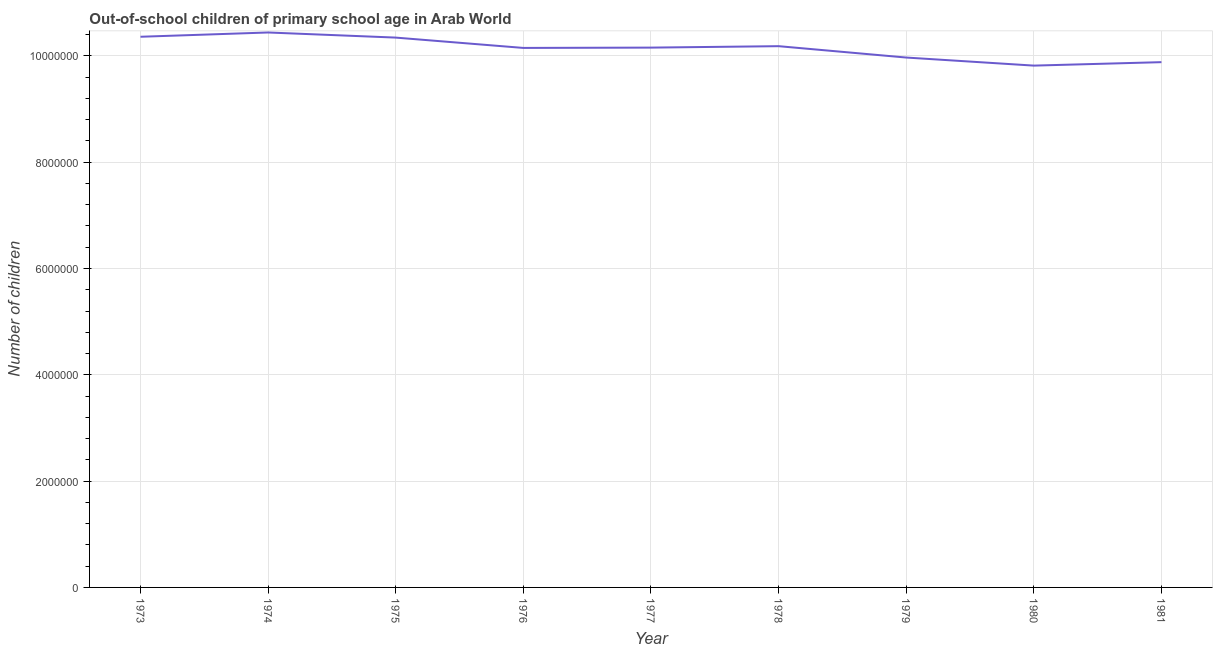What is the number of out-of-school children in 1973?
Your answer should be compact. 1.04e+07. Across all years, what is the maximum number of out-of-school children?
Ensure brevity in your answer.  1.04e+07. Across all years, what is the minimum number of out-of-school children?
Your answer should be very brief. 9.82e+06. In which year was the number of out-of-school children maximum?
Offer a very short reply. 1974. What is the sum of the number of out-of-school children?
Your response must be concise. 9.13e+07. What is the difference between the number of out-of-school children in 1977 and 1978?
Offer a terse response. -2.72e+04. What is the average number of out-of-school children per year?
Offer a very short reply. 1.01e+07. What is the median number of out-of-school children?
Make the answer very short. 1.02e+07. In how many years, is the number of out-of-school children greater than 7600000 ?
Your answer should be compact. 9. What is the ratio of the number of out-of-school children in 1977 to that in 1981?
Provide a succinct answer. 1.03. Is the number of out-of-school children in 1975 less than that in 1979?
Offer a terse response. No. Is the difference between the number of out-of-school children in 1974 and 1981 greater than the difference between any two years?
Ensure brevity in your answer.  No. What is the difference between the highest and the second highest number of out-of-school children?
Offer a terse response. 8.05e+04. What is the difference between the highest and the lowest number of out-of-school children?
Offer a terse response. 6.23e+05. Does the number of out-of-school children monotonically increase over the years?
Provide a short and direct response. No. What is the difference between two consecutive major ticks on the Y-axis?
Provide a succinct answer. 2.00e+06. Does the graph contain any zero values?
Provide a succinct answer. No. Does the graph contain grids?
Give a very brief answer. Yes. What is the title of the graph?
Keep it short and to the point. Out-of-school children of primary school age in Arab World. What is the label or title of the Y-axis?
Offer a very short reply. Number of children. What is the Number of children of 1973?
Give a very brief answer. 1.04e+07. What is the Number of children in 1974?
Offer a very short reply. 1.04e+07. What is the Number of children in 1975?
Provide a short and direct response. 1.03e+07. What is the Number of children in 1976?
Provide a short and direct response. 1.02e+07. What is the Number of children in 1977?
Your answer should be very brief. 1.02e+07. What is the Number of children in 1978?
Provide a succinct answer. 1.02e+07. What is the Number of children of 1979?
Make the answer very short. 9.97e+06. What is the Number of children in 1980?
Give a very brief answer. 9.82e+06. What is the Number of children of 1981?
Your answer should be compact. 9.88e+06. What is the difference between the Number of children in 1973 and 1974?
Provide a succinct answer. -8.05e+04. What is the difference between the Number of children in 1973 and 1975?
Make the answer very short. 1.58e+04. What is the difference between the Number of children in 1973 and 1976?
Your response must be concise. 2.10e+05. What is the difference between the Number of children in 1973 and 1977?
Offer a terse response. 2.04e+05. What is the difference between the Number of children in 1973 and 1978?
Keep it short and to the point. 1.77e+05. What is the difference between the Number of children in 1973 and 1979?
Offer a very short reply. 3.91e+05. What is the difference between the Number of children in 1973 and 1980?
Your answer should be compact. 5.43e+05. What is the difference between the Number of children in 1973 and 1981?
Provide a succinct answer. 4.78e+05. What is the difference between the Number of children in 1974 and 1975?
Your response must be concise. 9.63e+04. What is the difference between the Number of children in 1974 and 1976?
Your response must be concise. 2.91e+05. What is the difference between the Number of children in 1974 and 1977?
Keep it short and to the point. 2.85e+05. What is the difference between the Number of children in 1974 and 1978?
Ensure brevity in your answer.  2.58e+05. What is the difference between the Number of children in 1974 and 1979?
Provide a short and direct response. 4.71e+05. What is the difference between the Number of children in 1974 and 1980?
Your response must be concise. 6.23e+05. What is the difference between the Number of children in 1974 and 1981?
Give a very brief answer. 5.58e+05. What is the difference between the Number of children in 1975 and 1976?
Your answer should be compact. 1.94e+05. What is the difference between the Number of children in 1975 and 1977?
Make the answer very short. 1.88e+05. What is the difference between the Number of children in 1975 and 1978?
Provide a short and direct response. 1.61e+05. What is the difference between the Number of children in 1975 and 1979?
Offer a terse response. 3.75e+05. What is the difference between the Number of children in 1975 and 1980?
Keep it short and to the point. 5.27e+05. What is the difference between the Number of children in 1975 and 1981?
Make the answer very short. 4.62e+05. What is the difference between the Number of children in 1976 and 1977?
Your answer should be compact. -5879. What is the difference between the Number of children in 1976 and 1978?
Provide a short and direct response. -3.31e+04. What is the difference between the Number of children in 1976 and 1979?
Provide a short and direct response. 1.81e+05. What is the difference between the Number of children in 1976 and 1980?
Provide a succinct answer. 3.33e+05. What is the difference between the Number of children in 1976 and 1981?
Provide a succinct answer. 2.68e+05. What is the difference between the Number of children in 1977 and 1978?
Offer a very short reply. -2.72e+04. What is the difference between the Number of children in 1977 and 1979?
Provide a succinct answer. 1.87e+05. What is the difference between the Number of children in 1977 and 1980?
Your answer should be very brief. 3.39e+05. What is the difference between the Number of children in 1977 and 1981?
Your response must be concise. 2.73e+05. What is the difference between the Number of children in 1978 and 1979?
Your answer should be compact. 2.14e+05. What is the difference between the Number of children in 1978 and 1980?
Provide a succinct answer. 3.66e+05. What is the difference between the Number of children in 1978 and 1981?
Provide a short and direct response. 3.01e+05. What is the difference between the Number of children in 1979 and 1980?
Provide a succinct answer. 1.52e+05. What is the difference between the Number of children in 1979 and 1981?
Give a very brief answer. 8.68e+04. What is the difference between the Number of children in 1980 and 1981?
Make the answer very short. -6.51e+04. What is the ratio of the Number of children in 1973 to that in 1974?
Give a very brief answer. 0.99. What is the ratio of the Number of children in 1973 to that in 1975?
Make the answer very short. 1. What is the ratio of the Number of children in 1973 to that in 1979?
Offer a terse response. 1.04. What is the ratio of the Number of children in 1973 to that in 1980?
Your answer should be compact. 1.05. What is the ratio of the Number of children in 1973 to that in 1981?
Offer a terse response. 1.05. What is the ratio of the Number of children in 1974 to that in 1975?
Offer a terse response. 1.01. What is the ratio of the Number of children in 1974 to that in 1977?
Keep it short and to the point. 1.03. What is the ratio of the Number of children in 1974 to that in 1978?
Keep it short and to the point. 1.02. What is the ratio of the Number of children in 1974 to that in 1979?
Provide a succinct answer. 1.05. What is the ratio of the Number of children in 1974 to that in 1980?
Offer a very short reply. 1.06. What is the ratio of the Number of children in 1974 to that in 1981?
Offer a very short reply. 1.06. What is the ratio of the Number of children in 1975 to that in 1976?
Keep it short and to the point. 1.02. What is the ratio of the Number of children in 1975 to that in 1977?
Your answer should be very brief. 1.02. What is the ratio of the Number of children in 1975 to that in 1978?
Ensure brevity in your answer.  1.02. What is the ratio of the Number of children in 1975 to that in 1979?
Your answer should be very brief. 1.04. What is the ratio of the Number of children in 1975 to that in 1980?
Ensure brevity in your answer.  1.05. What is the ratio of the Number of children in 1975 to that in 1981?
Offer a very short reply. 1.05. What is the ratio of the Number of children in 1976 to that in 1980?
Offer a terse response. 1.03. What is the ratio of the Number of children in 1976 to that in 1981?
Your response must be concise. 1.03. What is the ratio of the Number of children in 1977 to that in 1978?
Give a very brief answer. 1. What is the ratio of the Number of children in 1977 to that in 1980?
Provide a short and direct response. 1.03. What is the ratio of the Number of children in 1977 to that in 1981?
Provide a short and direct response. 1.03. What is the ratio of the Number of children in 1979 to that in 1981?
Provide a succinct answer. 1.01. 